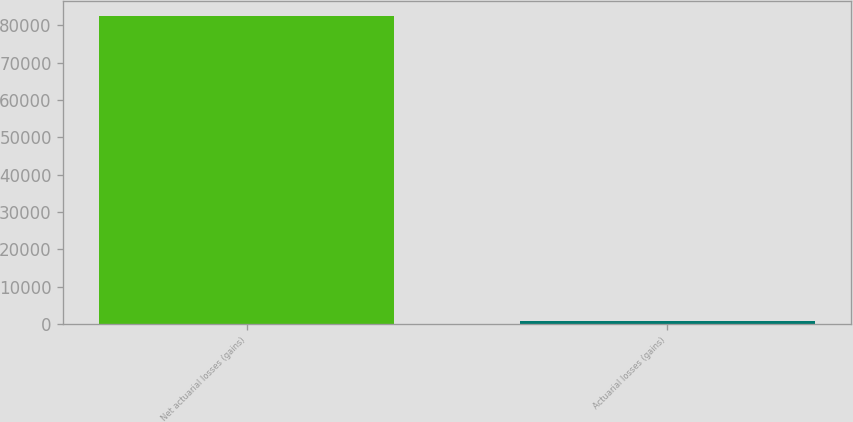Convert chart. <chart><loc_0><loc_0><loc_500><loc_500><bar_chart><fcel>Net actuarial losses (gains)<fcel>Actuarial losses (gains)<nl><fcel>82427<fcel>845<nl></chart> 